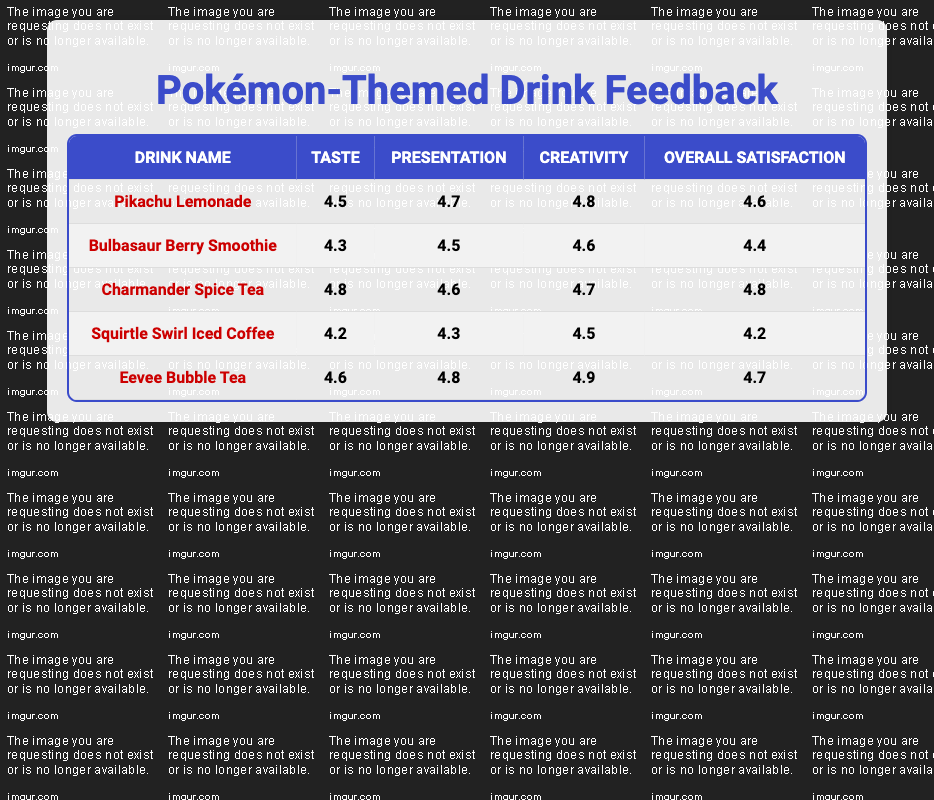What is the highest rated drink for creativity? The drink with the highest creativity rating is “Eevee Bubble Tea,” which has a score of 4.9.
Answer: Eevee Bubble Tea Which drink has the lowest overall satisfaction rating? The drink with the lowest overall satisfaction rating is “Squirtle Swirl Iced Coffee,” which has a score of 4.2.
Answer: Squirtle Swirl Iced Coffee What is the average taste rating for all drinks? To find the average taste rating, sum the ratings: (4.5 + 4.3 + 4.8 + 4.2 + 4.6) = 22.4. There are 5 drinks, so the average is 22.4 / 5 = 4.48.
Answer: 4.48 Is the creativity rating for “Pikachu Lemonade” higher than that for “Bulbasaur Berry Smoothie”? “Pikachu Lemonade” has a creativity rating of 4.8, which is higher than the 4.6 rating for “Bulbasaur Berry Smoothie.” Therefore, the statement is true.
Answer: Yes Which drink has the highest overall satisfaction rating, and what is that rating? The drink with the highest overall satisfaction rating is “Charmander Spice Tea,” which has a rating of 4.8.
Answer: 4.8 